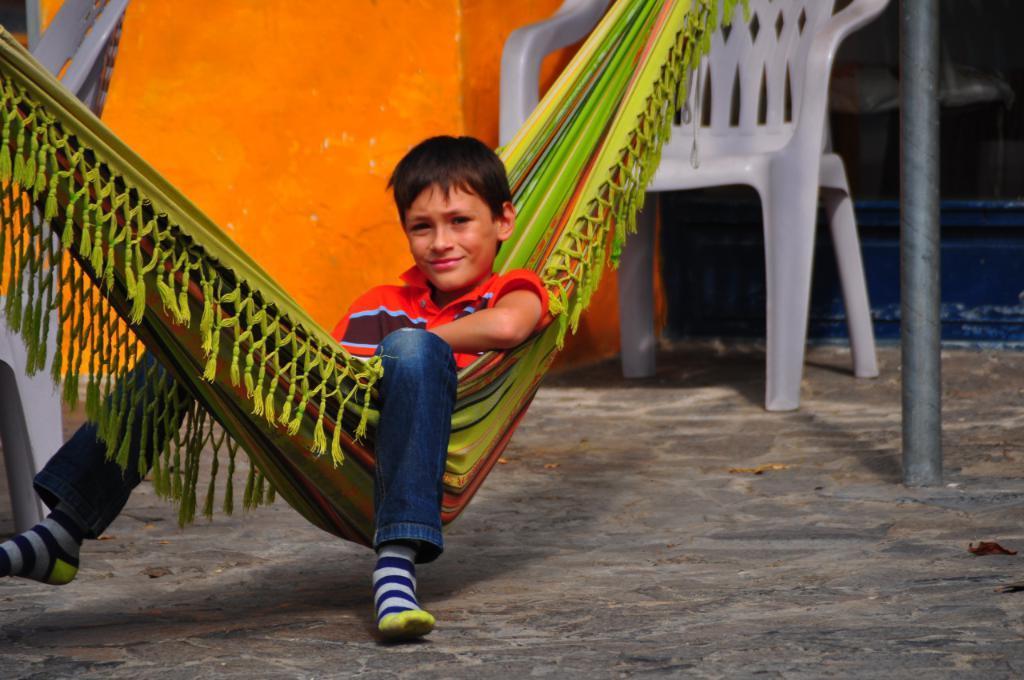How would you summarize this image in a sentence or two? In this picture we can see a boy siiting on a cloth swing. On the background we can see a wall, chair. This is a pole. 